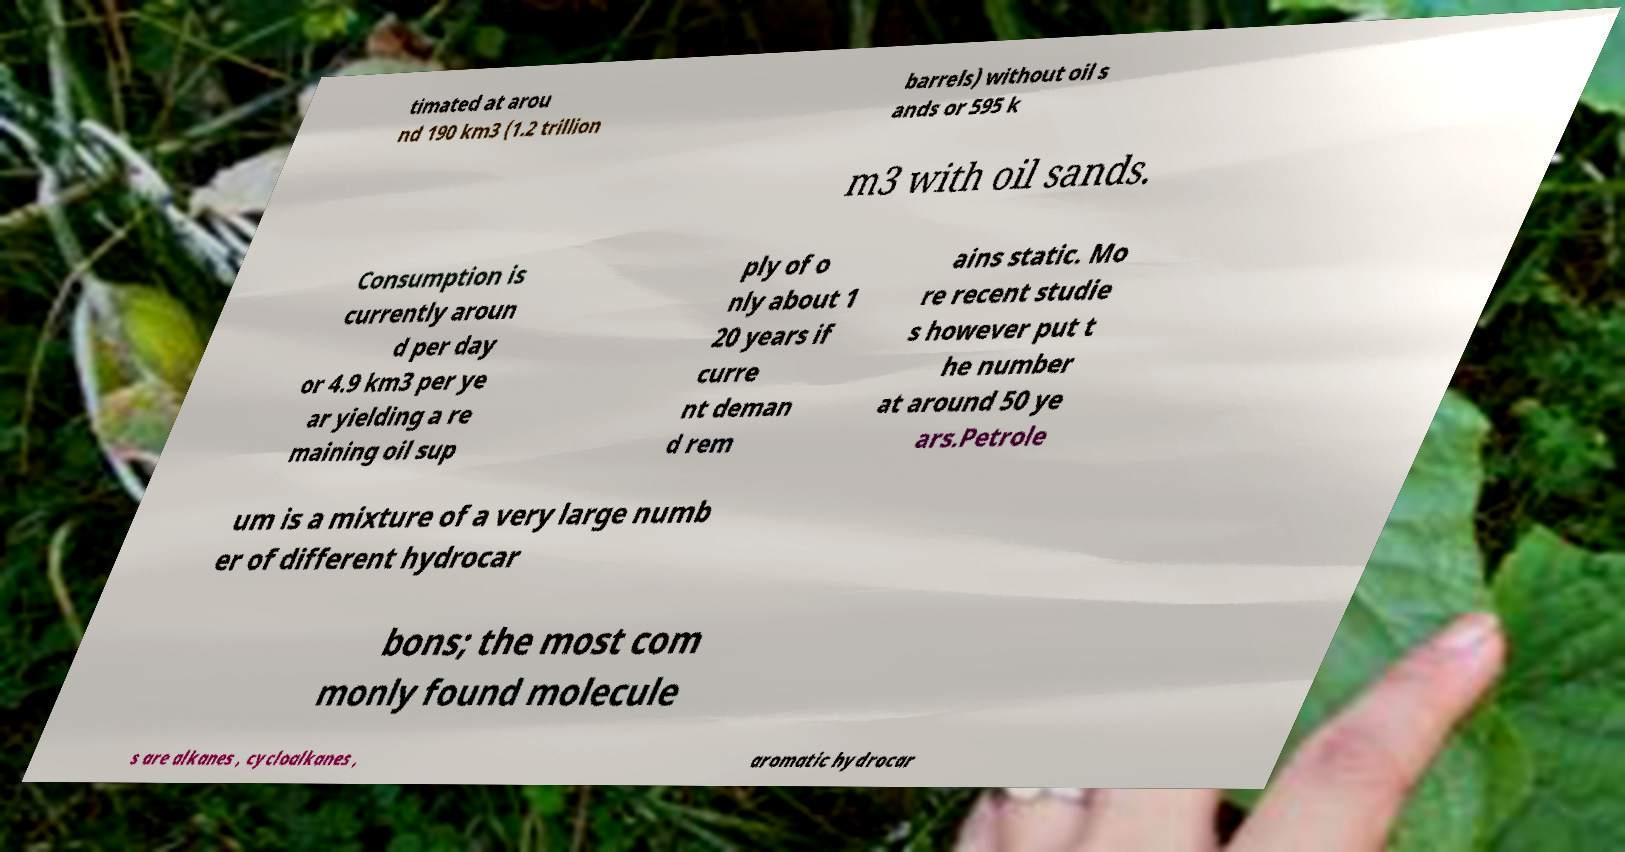What messages or text are displayed in this image? I need them in a readable, typed format. timated at arou nd 190 km3 (1.2 trillion barrels) without oil s ands or 595 k m3 with oil sands. Consumption is currently aroun d per day or 4.9 km3 per ye ar yielding a re maining oil sup ply of o nly about 1 20 years if curre nt deman d rem ains static. Mo re recent studie s however put t he number at around 50 ye ars.Petrole um is a mixture of a very large numb er of different hydrocar bons; the most com monly found molecule s are alkanes , cycloalkanes , aromatic hydrocar 